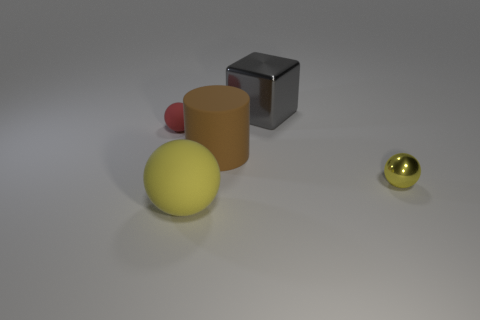Is the tiny metal thing the same color as the large rubber sphere?
Your answer should be compact. Yes. Does the large object that is in front of the yellow metal object have the same color as the tiny shiny ball?
Your answer should be compact. Yes. There is a thing that is behind the tiny yellow object and left of the brown rubber cylinder; what is it made of?
Keep it short and to the point. Rubber. Is the yellow object left of the brown rubber cylinder made of the same material as the tiny ball that is to the left of the big cylinder?
Offer a terse response. Yes. What size is the red thing?
Give a very brief answer. Small. There is a yellow metal object that is the same shape as the red matte thing; what size is it?
Your response must be concise. Small. How many spheres are behind the yellow matte ball?
Your response must be concise. 2. What is the color of the rubber thing on the left side of the large thing left of the big brown cylinder?
Make the answer very short. Red. Are there any other things that are the same shape as the big gray metallic thing?
Offer a terse response. No. Are there the same number of red objects in front of the gray cube and brown cylinders that are in front of the small red thing?
Offer a terse response. Yes. 